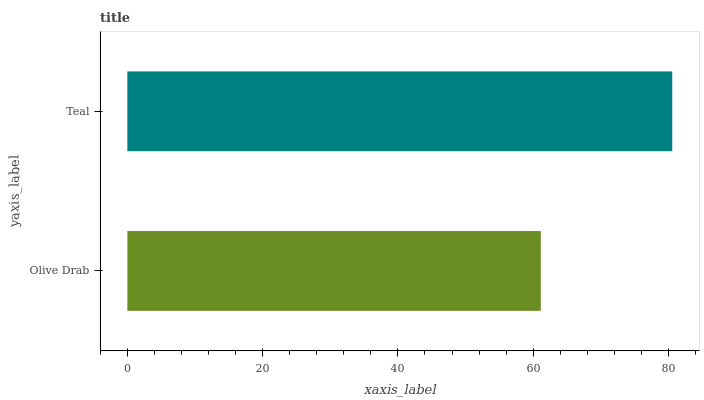Is Olive Drab the minimum?
Answer yes or no. Yes. Is Teal the maximum?
Answer yes or no. Yes. Is Teal the minimum?
Answer yes or no. No. Is Teal greater than Olive Drab?
Answer yes or no. Yes. Is Olive Drab less than Teal?
Answer yes or no. Yes. Is Olive Drab greater than Teal?
Answer yes or no. No. Is Teal less than Olive Drab?
Answer yes or no. No. Is Teal the high median?
Answer yes or no. Yes. Is Olive Drab the low median?
Answer yes or no. Yes. Is Olive Drab the high median?
Answer yes or no. No. Is Teal the low median?
Answer yes or no. No. 